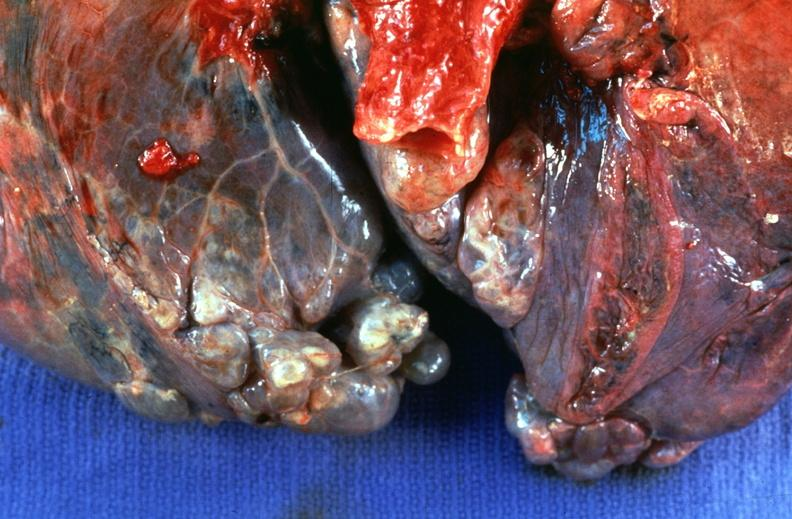s close-up excellent example of interosseous muscle atrophy present?
Answer the question using a single word or phrase. No 